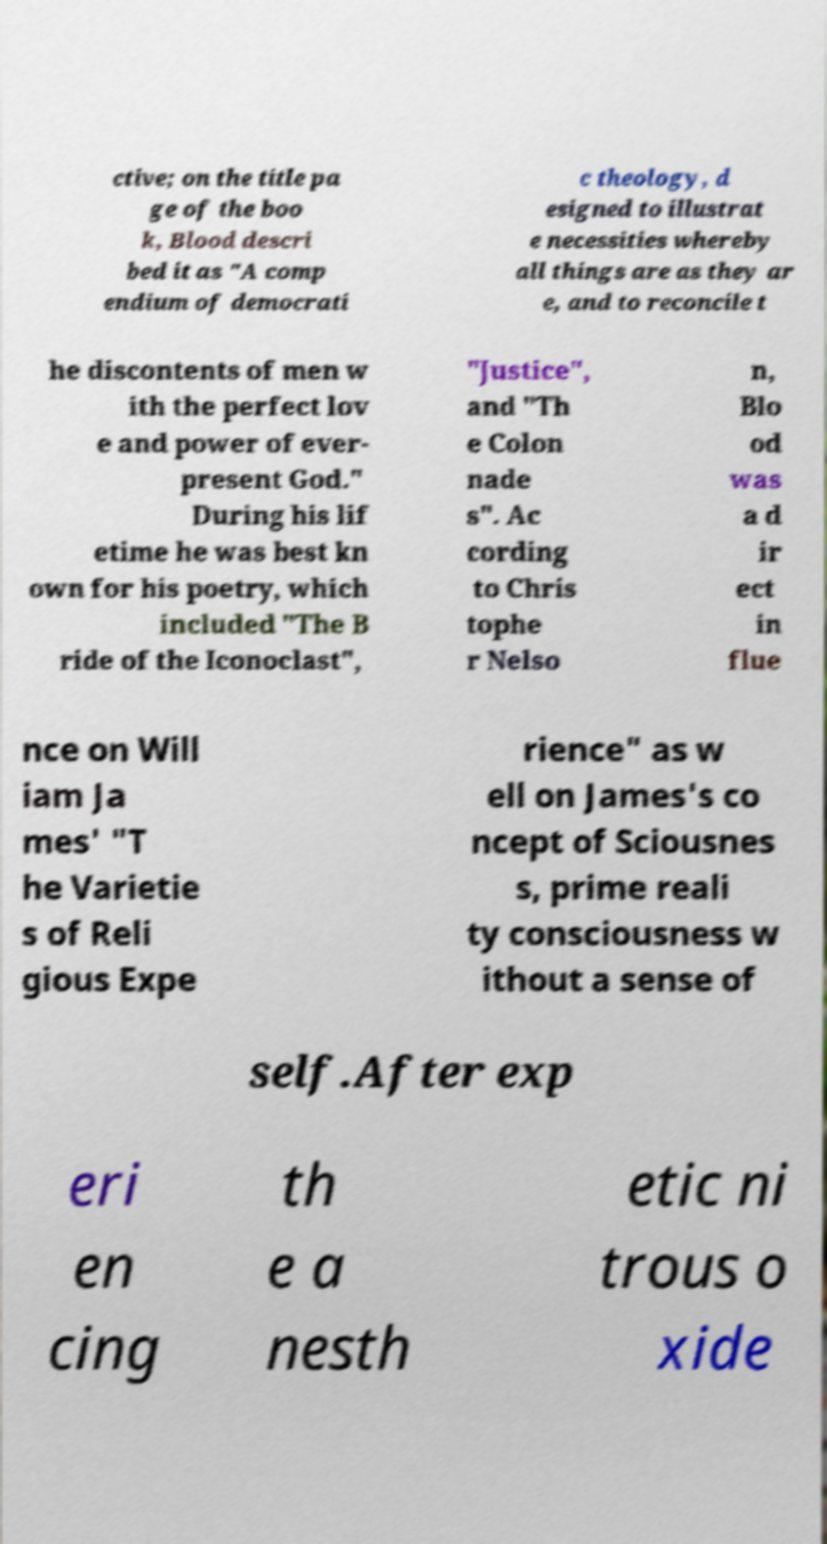Could you extract and type out the text from this image? ctive; on the title pa ge of the boo k, Blood descri bed it as "A comp endium of democrati c theology, d esigned to illustrat e necessities whereby all things are as they ar e, and to reconcile t he discontents of men w ith the perfect lov e and power of ever- present God." During his lif etime he was best kn own for his poetry, which included "The B ride of the Iconoclast", "Justice", and "Th e Colon nade s". Ac cording to Chris tophe r Nelso n, Blo od was a d ir ect in flue nce on Will iam Ja mes' "T he Varietie s of Reli gious Expe rience" as w ell on James's co ncept of Sciousnes s, prime reali ty consciousness w ithout a sense of self.After exp eri en cing th e a nesth etic ni trous o xide 